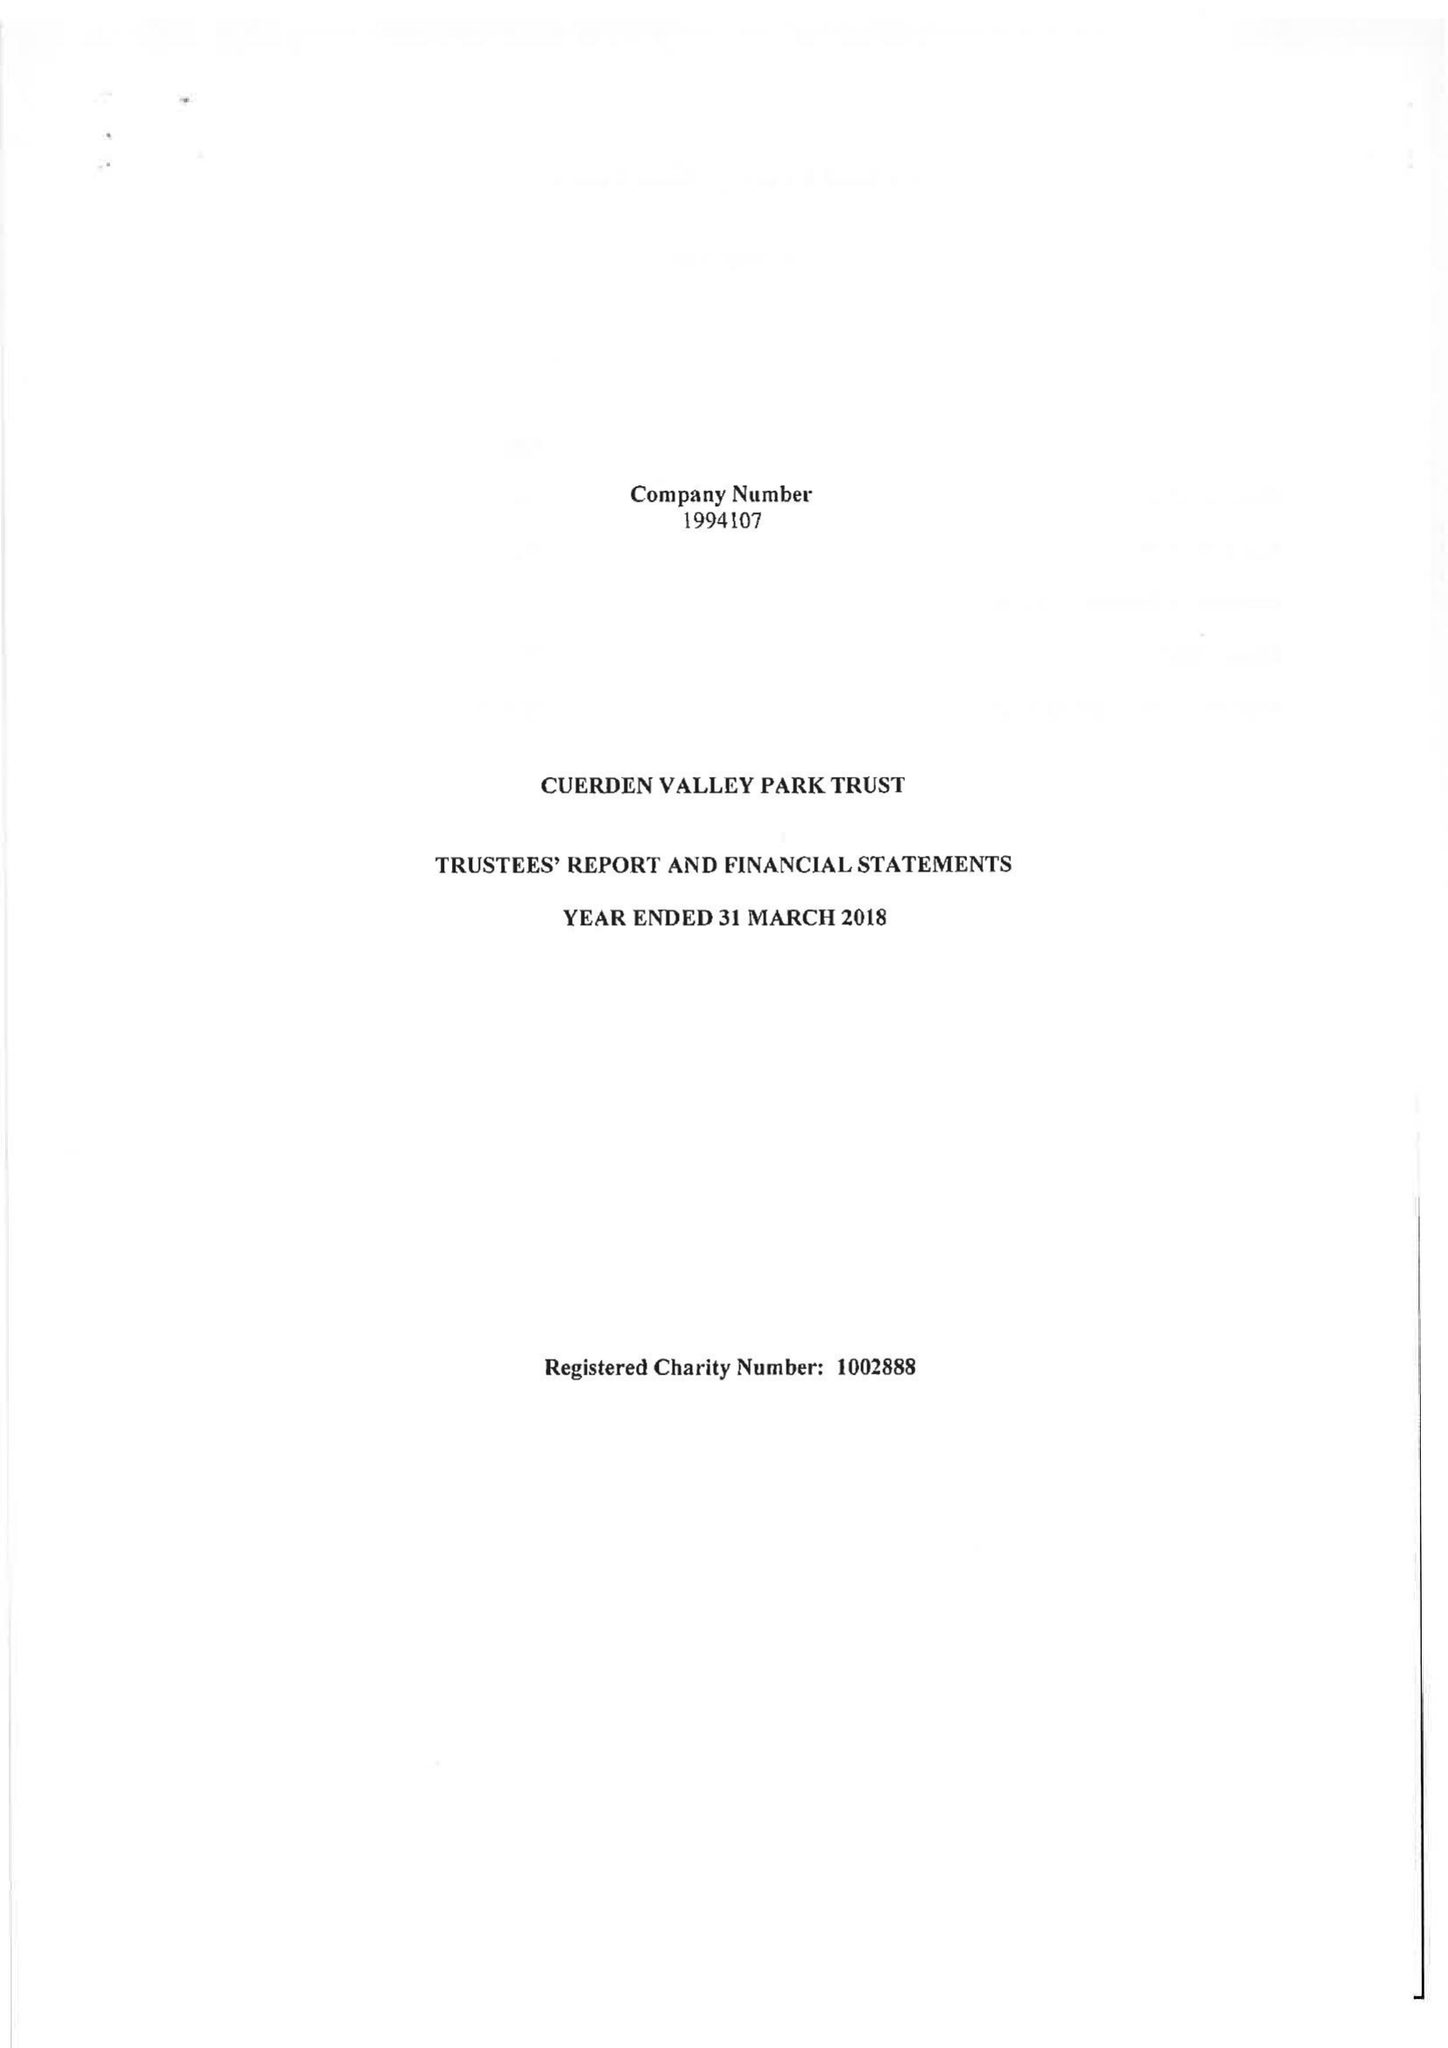What is the value for the address__street_line?
Answer the question using a single word or phrase. BERKELEY DRIVE 